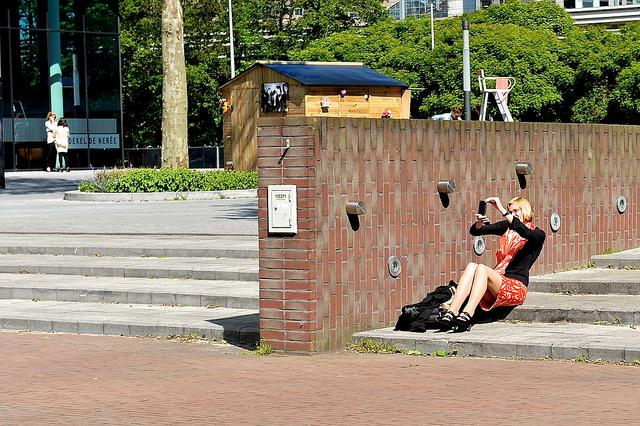Why does the woman have her arms out?

Choices:
A) measure
B) take picture
C) wave
D) balance take picture 